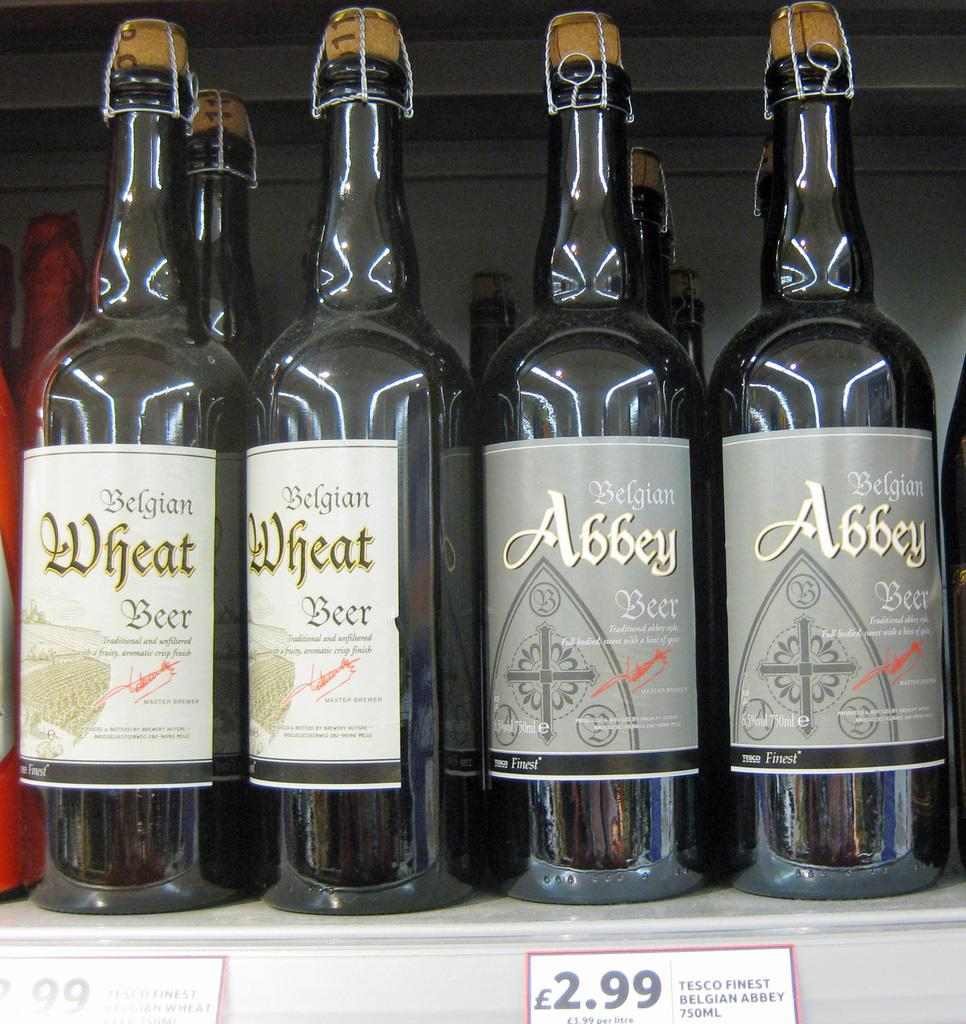<image>
Write a terse but informative summary of the picture. Among the beer bottles are Belgian Abbey Beer. 